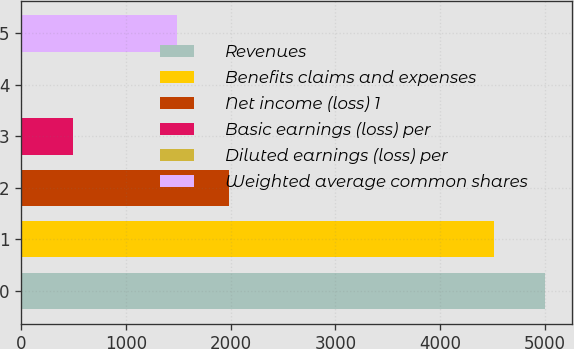Convert chart. <chart><loc_0><loc_0><loc_500><loc_500><bar_chart><fcel>Revenues<fcel>Benefits claims and expenses<fcel>Net income (loss) 1<fcel>Basic earnings (loss) per<fcel>Diluted earnings (loss) per<fcel>Weighted average common shares<nl><fcel>5005.58<fcel>4511<fcel>1979.52<fcel>495.78<fcel>1.2<fcel>1484.94<nl></chart> 